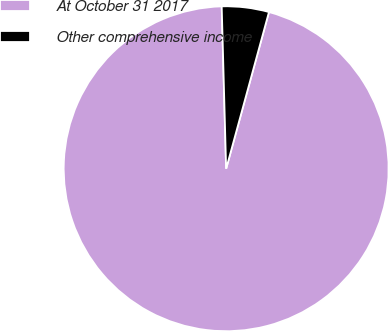Convert chart. <chart><loc_0><loc_0><loc_500><loc_500><pie_chart><fcel>At October 31 2017<fcel>Other comprehensive income<nl><fcel>95.32%<fcel>4.68%<nl></chart> 